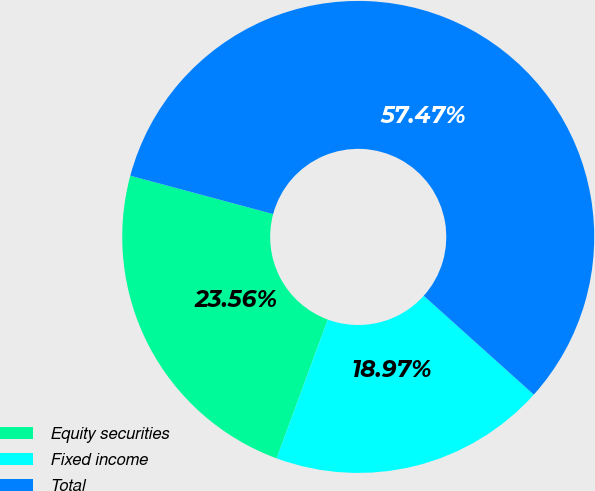<chart> <loc_0><loc_0><loc_500><loc_500><pie_chart><fcel>Equity securities<fcel>Fixed income<fcel>Total<nl><fcel>23.56%<fcel>18.97%<fcel>57.47%<nl></chart> 